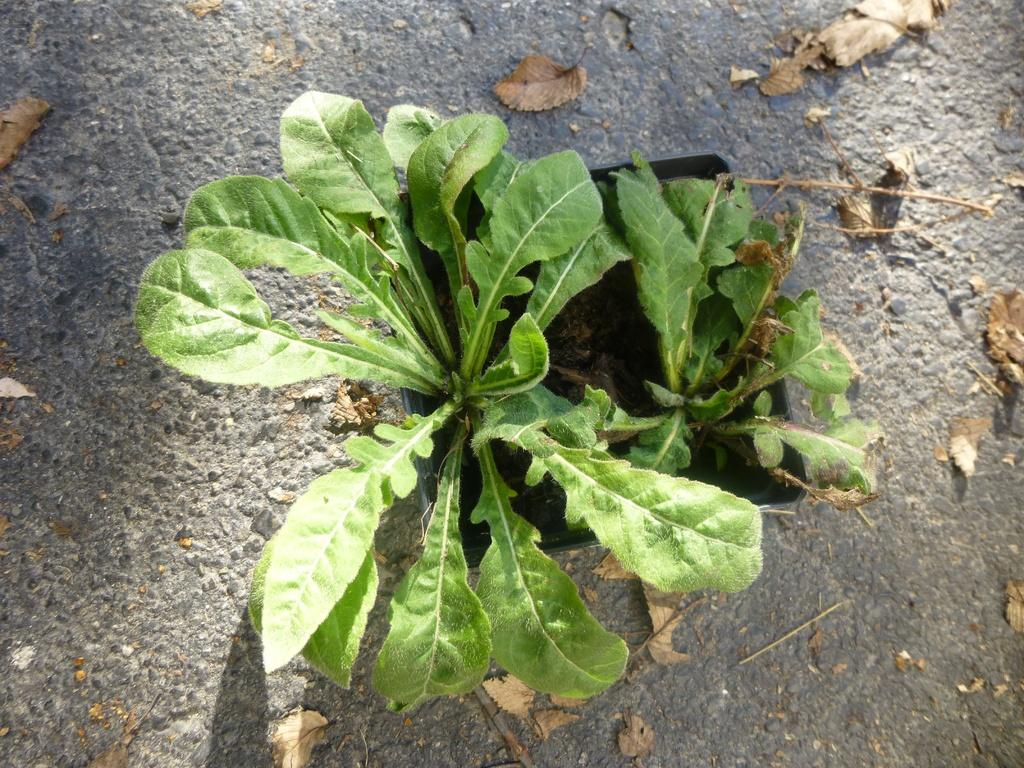What is in the pot that is visible in the image? There are two plants in a pot in the image. What can be seen on the ground in the image? There are brown color leaves on the ground in the image. How many trucks are parked under the veil in the image? There is no veil or trucks present in the image. What type of water can be seen flowing through the image? There is no water present in the image. 